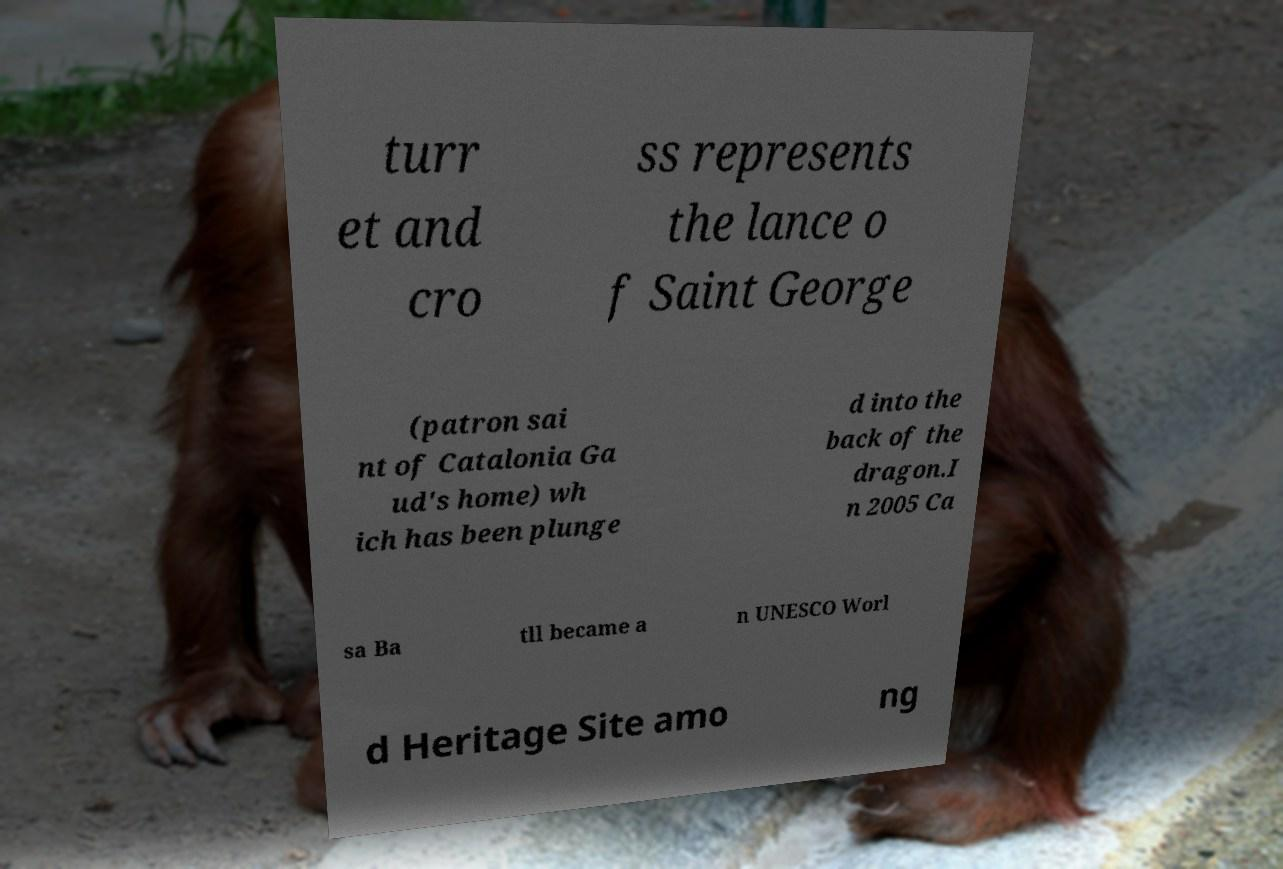Can you read and provide the text displayed in the image?This photo seems to have some interesting text. Can you extract and type it out for me? turr et and cro ss represents the lance o f Saint George (patron sai nt of Catalonia Ga ud's home) wh ich has been plunge d into the back of the dragon.I n 2005 Ca sa Ba tll became a n UNESCO Worl d Heritage Site amo ng 